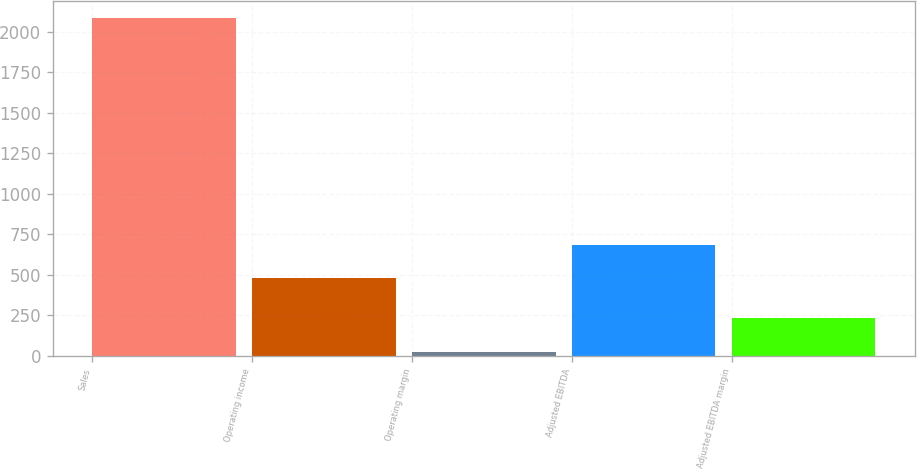Convert chart to OTSL. <chart><loc_0><loc_0><loc_500><loc_500><bar_chart><fcel>Sales<fcel>Operating income<fcel>Operating margin<fcel>Adjusted EBITDA<fcel>Adjusted EBITDA margin<nl><fcel>2087.1<fcel>476.7<fcel>22.8<fcel>683.13<fcel>229.23<nl></chart> 